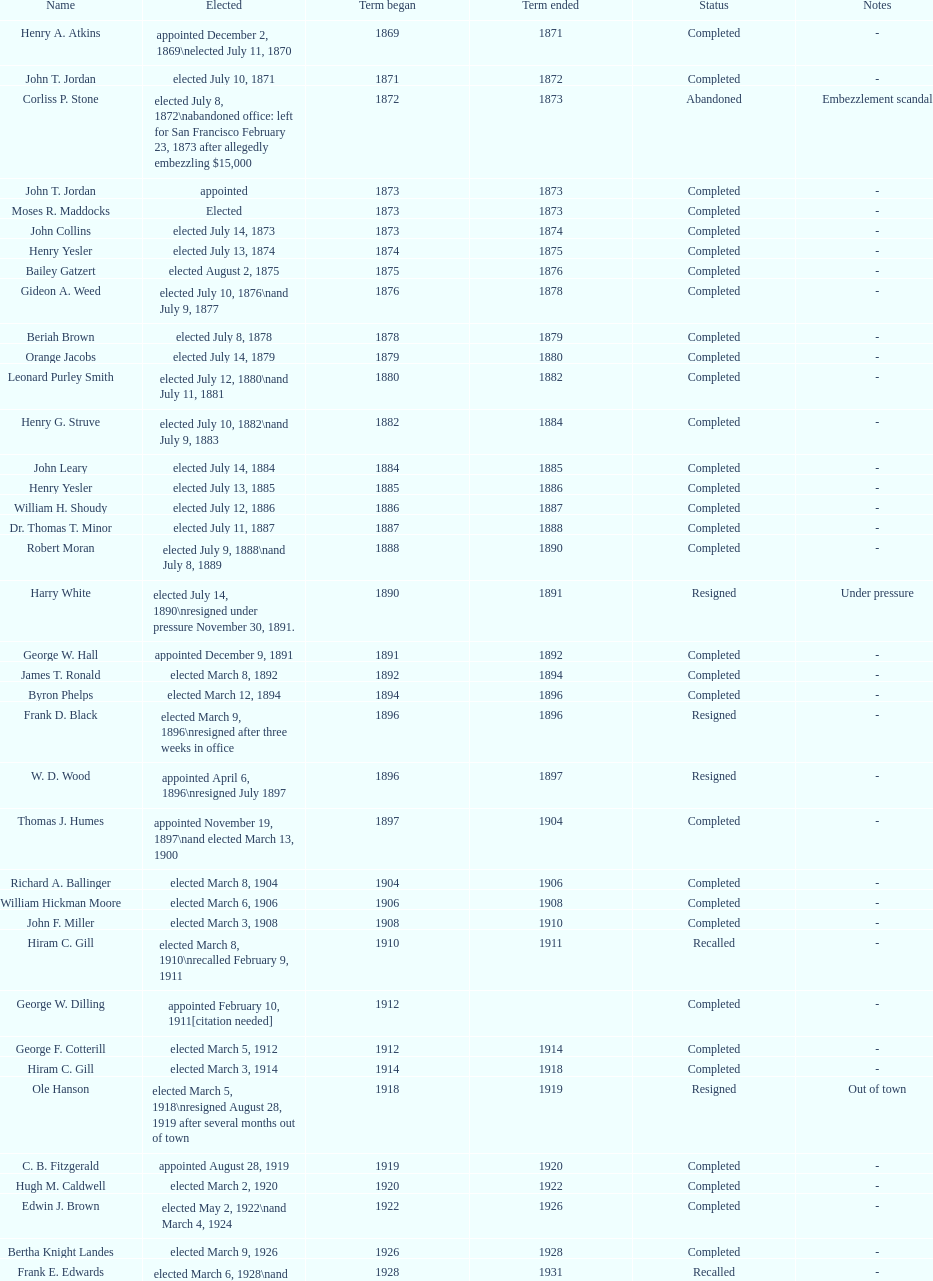How many days did robert moran serve? 365. 